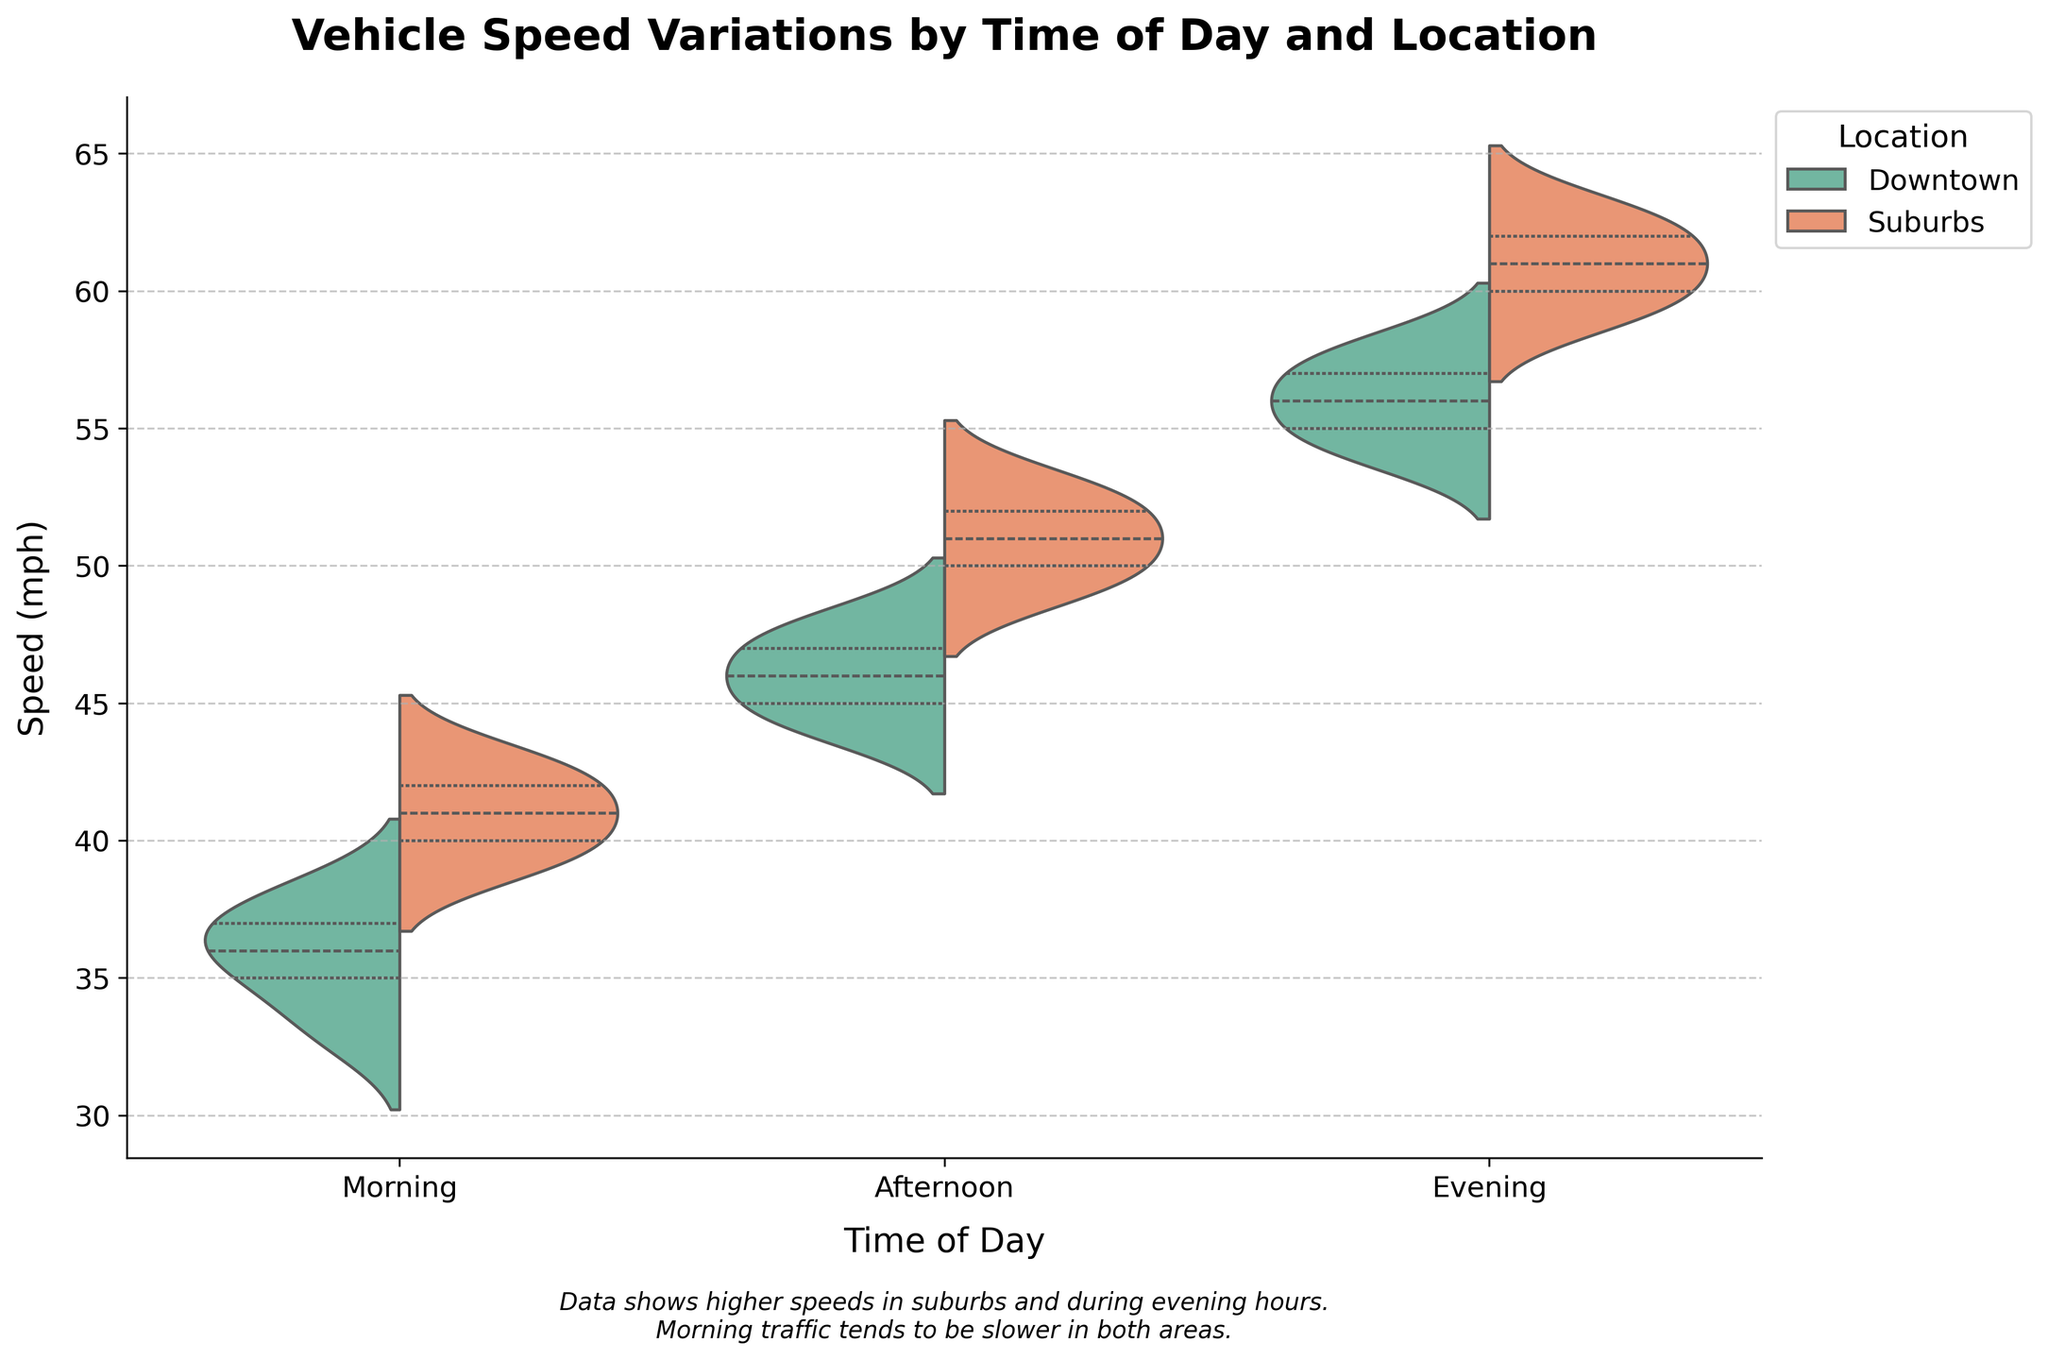What is the title of the figure? The title is located at the top of the figure and provides a summary of the content being displayed. The title of the figure is 'Vehicle Speed Variations by Time of Day and Location'.
Answer: Vehicle Speed Variations by Time of Day and Location What is the range of speeds (mph) for Downtown in the evening? Look at the violin plot for the 'Evening' time period and focus on the 'Downtown' category. The range is from the minimum to the maximum speed.
Answer: 54 to 58 In which time period do the vehicles in the suburbs have the highest median speed? The median speed is indicated by the white dot within each violin plot. Compare the position of white dots in the 'Suburbs' category across the different time periods.
Answer: Evening Which location has a wider range of speeds in the afternoon? Compare the range of speeds for 'Downtown' and 'Suburbs' during the 'Afternoon' by looking at the height of their respective violin plots. The 'Suburbs' has a wider range because the plot stretches further in both directions.
Answer: Suburbs How does the average speed in the morning compare between Downtown and Suburbs? Estimate the central tendency for both 'Downtown' and 'Suburbs' during the 'Morning' by assessing the average position where the data is densest within the violin plots.
Answer: Higher in Suburbs Are speeds generally higher in the afternoon or the morning? Compare the ranges and medians of speeds for all categories in the 'Morning' and 'Afternoon' violin plots. Speeds are generally higher in the afternoon.
Answer: Afternoon What is the overall trend in vehicle speed throughout the day for both locations? Assess the changes in speed from 'Morning' to 'Afternoon' to 'Evening' by observing the progression of the violin plots for both 'Downtown' and 'Suburbs'.
Answer: Speeds increase from morning to evening 